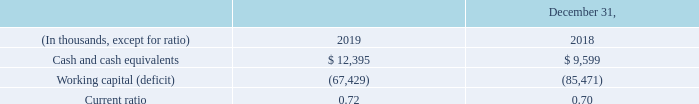Sufficiency of Cash Resources The following table sets forth selected information regarding our financial condition:
Our net working capital position improved $18.0 million as of December 31, 2019 compared to December 31, 2018 primarily as a result of the elimination in 2019 of the quarterly dividend of approximately $27.6 million and a decrease in accrued compensation of $7.4 million.
These reductions in the working capital deficit were offset in part by the recognition of current lease liabilities of $6.2 million at December 31, 2019 as part of the adoption on January 1, 2019 of ASU No. 2016- 02, Leases. Working capital was also impacted by a decline in accounts receivable of $13.1 million compared to December 31, 2018.
Our most significant use of funds in 2020 is expected to be for: (i) interest payments on our indebtedness of between $125.0 million and $130.0 million and principal payments on debt of $18.4 million; and (ii) capital expenditures of between $195.0 million and $205.0 million.
Based on available cash, we may utilize a portion of the dividend savings to reduce our longterm debt or repurchase additional amounts of our Senior Notes in the open market or in private transactions if such purchases can be made on economically favorable terms. In the future, our ability to use cash may be limited by our other expected uses of cash and our ability to incur additional debt will be limited by our existing and future debt agreements.
We believe that cash flows from operating activities, together with our existing cash and borrowings available under our revolving credit facility, will be sufficient for at least the next twelve months to fund our current anticipated uses of cash.
After that, our ability to fund these expected uses of cash and to comply with the financial covenants under our debt agreements will depend on the results of future operations, performance and cash flow. Our ability to fund these expected uses from the results of future operations will be subject to prevailing economic conditions and to financial, business, regulatory, legislative and other factors, many of which are beyond our control.
We may be unable to access the cash flows of our subsidiaries since certain of our subsidiaries are parties to credit or other borrowing agreements, or subject to statutory or regulatory restrictions, that restrict the payment of dividends or making intercompany loans and investments, and those subsidiaries are likely to continue to be subject to such restrictions and prohibitions for the foreseeable future.
In addition, future agreements that our subsidiaries may enter into governing the terms of indebtedness may restrict our subsidiaries’ ability to pay dividends or advance cash in any other manner to us.
To the extent that our business plans or projections change or prove to be inaccurate, we may require additional financing or require financing sooner than we currently anticipate. Sources of additional financing may include commercial bank borrowings, other strategic debt financing, sales of nonstrategic assets, vendor financing or the private or public sales of equity and debt securities.
There can be no assurance that we will be able to generate sufficient cash flows from operations in the future, that anticipated revenue growth will be realized, or that future borrowings or equity issuances will be available in amounts sufficient to provide adequate sources of cash to fund our expected uses of cash. Failure to obtain adequate financing, if necessary, could require us to significantly reduce our operations or level of capital expenditures, which could have a material adverse effect on our financial condition and the results of operations.
What was net working capital position improvement in 2019 compared to 2018? $18.0 million. What was the quarterly dividend elimination value in 2019? $27.6 million. What was the current lease liability in 2019? $6.2 million. What was the increase / (decrease) in the cash and cash equivalent from 2018 to 2019?
Answer scale should be: thousand. 12,395 - 9,599
Answer: 2796. What was the average working capital deficit for 2018 to 2019?
Answer scale should be: thousand. -(67,429 + 85,471) / 2
Answer: -76450. What was the increase / (decrease) in the current ratio from 2018 to 2019? 0.72 - 0.70
Answer: 0.02. 